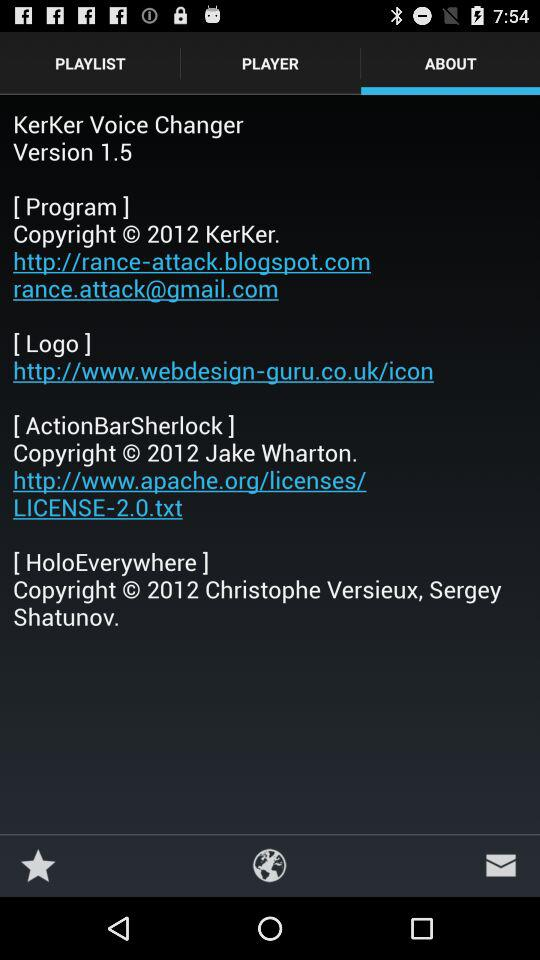Which version is used? The used version is 1.5. 